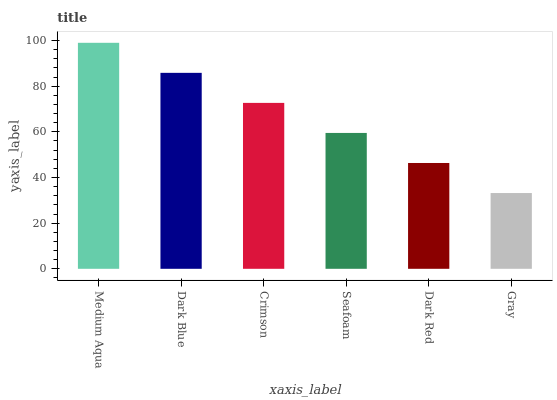Is Gray the minimum?
Answer yes or no. Yes. Is Medium Aqua the maximum?
Answer yes or no. Yes. Is Dark Blue the minimum?
Answer yes or no. No. Is Dark Blue the maximum?
Answer yes or no. No. Is Medium Aqua greater than Dark Blue?
Answer yes or no. Yes. Is Dark Blue less than Medium Aqua?
Answer yes or no. Yes. Is Dark Blue greater than Medium Aqua?
Answer yes or no. No. Is Medium Aqua less than Dark Blue?
Answer yes or no. No. Is Crimson the high median?
Answer yes or no. Yes. Is Seafoam the low median?
Answer yes or no. Yes. Is Dark Red the high median?
Answer yes or no. No. Is Gray the low median?
Answer yes or no. No. 